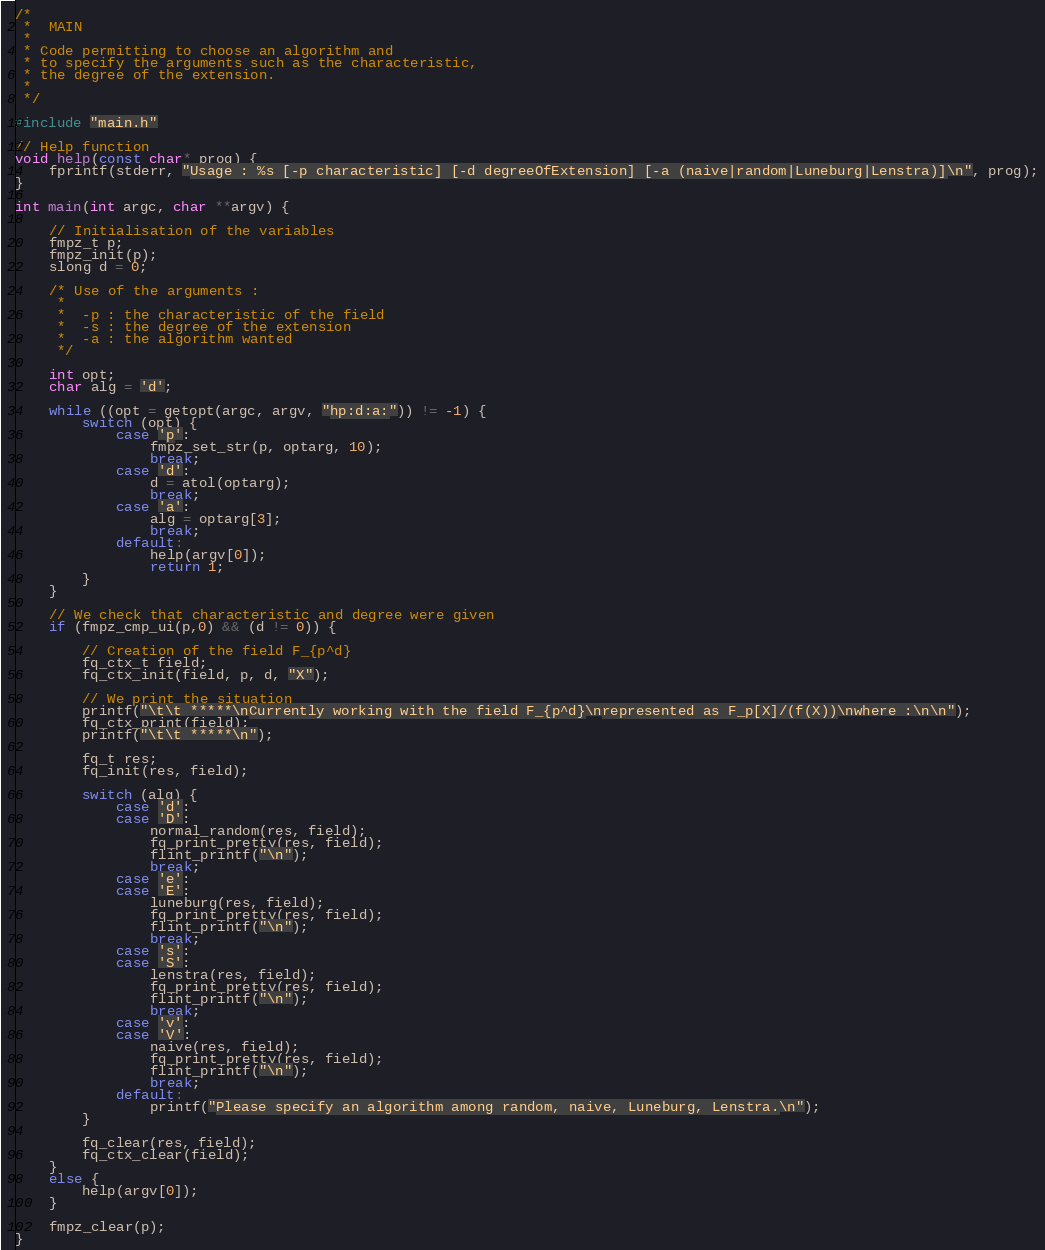Convert code to text. <code><loc_0><loc_0><loc_500><loc_500><_C_>/*
 * 	MAIN
 *
 * Code permitting to choose an algorithm and
 * to specify the arguments such as the characteristic, 
 * the degree of the extension.
 *
 */

#include "main.h"

// Help function
void help(const char* prog) {
	fprintf(stderr, "Usage : %s [-p characteristic] [-d degreeOfExtension] [-a (naive|random|Luneburg|Lenstra)]\n", prog);
}

int main(int argc, char **argv) {

	// Initialisation of the variables
	fmpz_t p;
	fmpz_init(p);
	slong d = 0;

	/* Use of the arguments :
	 *
	 * 	-p : the characteristic of the field
	 * 	-s : the degree of the extension
	 * 	-a : the algorithm wanted
	 */
	
	int opt;
	char alg = 'd';

	while ((opt = getopt(argc, argv, "hp:d:a:")) != -1) {
		switch (opt) {
			case 'p':
				fmpz_set_str(p, optarg, 10);
				break;
			case 'd':
				d = atol(optarg);
				break;
			case 'a':
				alg = optarg[3];
				break;
			default:
				help(argv[0]);
				return 1;
		}
	}

	// We check that characteristic and degree were given
	if (fmpz_cmp_ui(p,0) && (d != 0)) {

		// Creation of the field F_{p^d}
		fq_ctx_t field;
		fq_ctx_init(field, p, d, "X");

		// We print the situation
		printf("\t\t *****\nCurrently working with the field F_{p^d}\nrepresented as F_p[X]/(f(X))\nwhere :\n\n");
		fq_ctx_print(field);
		printf("\t\t *****\n");

		fq_t res;
		fq_init(res, field);

		switch (alg) {
			case 'd':
			case 'D':
				normal_random(res, field);
				fq_print_pretty(res, field);
				flint_printf("\n");
				break;
			case 'e':
			case 'E':
				luneburg(res, field);
				fq_print_pretty(res, field);
				flint_printf("\n");
				break;
			case 's':
			case 'S':
				lenstra(res, field);
				fq_print_pretty(res, field);
				flint_printf("\n");
				break;
			case 'v':
			case 'V':
				naive(res, field);
				fq_print_pretty(res, field);
				flint_printf("\n");
				break;
			default:
				printf("Please specify an algorithm among random, naive, Luneburg, Lenstra.\n");
		}

		fq_clear(res, field);
		fq_ctx_clear(field);
	}
	else {
		help(argv[0]);
	}

	fmpz_clear(p);
}
</code> 